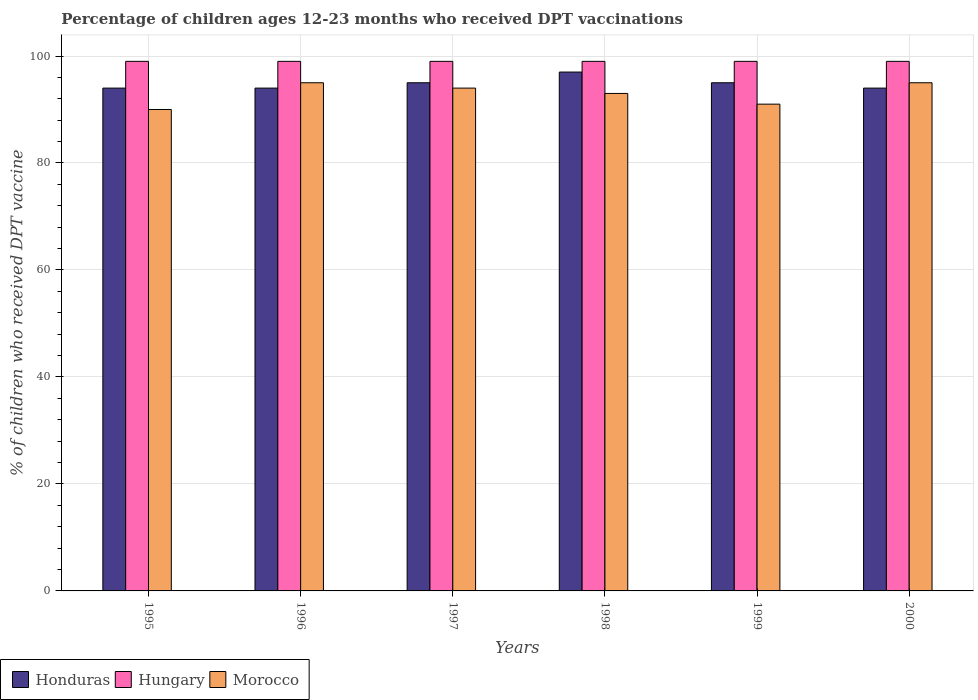How many bars are there on the 3rd tick from the left?
Make the answer very short. 3. What is the label of the 6th group of bars from the left?
Make the answer very short. 2000. In how many cases, is the number of bars for a given year not equal to the number of legend labels?
Offer a terse response. 0. What is the percentage of children who received DPT vaccination in Morocco in 2000?
Provide a succinct answer. 95. Across all years, what is the maximum percentage of children who received DPT vaccination in Hungary?
Provide a short and direct response. 99. Across all years, what is the minimum percentage of children who received DPT vaccination in Hungary?
Offer a very short reply. 99. In which year was the percentage of children who received DPT vaccination in Hungary minimum?
Offer a terse response. 1995. What is the total percentage of children who received DPT vaccination in Morocco in the graph?
Your answer should be compact. 558. What is the difference between the percentage of children who received DPT vaccination in Honduras in 1997 and that in 1999?
Offer a terse response. 0. What is the difference between the percentage of children who received DPT vaccination in Honduras in 1997 and the percentage of children who received DPT vaccination in Morocco in 1996?
Your response must be concise. 0. What is the average percentage of children who received DPT vaccination in Morocco per year?
Provide a short and direct response. 93. In the year 1998, what is the difference between the percentage of children who received DPT vaccination in Hungary and percentage of children who received DPT vaccination in Morocco?
Give a very brief answer. 6. In how many years, is the percentage of children who received DPT vaccination in Honduras greater than 80 %?
Offer a terse response. 6. What is the ratio of the percentage of children who received DPT vaccination in Honduras in 1998 to that in 1999?
Make the answer very short. 1.02. What is the difference between the highest and the second highest percentage of children who received DPT vaccination in Morocco?
Offer a very short reply. 0. Is the sum of the percentage of children who received DPT vaccination in Morocco in 1996 and 1999 greater than the maximum percentage of children who received DPT vaccination in Honduras across all years?
Make the answer very short. Yes. What does the 3rd bar from the left in 1997 represents?
Provide a short and direct response. Morocco. What does the 1st bar from the right in 1996 represents?
Keep it short and to the point. Morocco. Is it the case that in every year, the sum of the percentage of children who received DPT vaccination in Hungary and percentage of children who received DPT vaccination in Honduras is greater than the percentage of children who received DPT vaccination in Morocco?
Keep it short and to the point. Yes. Are all the bars in the graph horizontal?
Your answer should be very brief. No. How many years are there in the graph?
Keep it short and to the point. 6. Does the graph contain grids?
Keep it short and to the point. Yes. Where does the legend appear in the graph?
Offer a terse response. Bottom left. How many legend labels are there?
Make the answer very short. 3. What is the title of the graph?
Ensure brevity in your answer.  Percentage of children ages 12-23 months who received DPT vaccinations. Does "Sierra Leone" appear as one of the legend labels in the graph?
Your response must be concise. No. What is the label or title of the X-axis?
Provide a short and direct response. Years. What is the label or title of the Y-axis?
Your response must be concise. % of children who received DPT vaccine. What is the % of children who received DPT vaccine of Honduras in 1995?
Make the answer very short. 94. What is the % of children who received DPT vaccine in Hungary in 1995?
Your response must be concise. 99. What is the % of children who received DPT vaccine of Honduras in 1996?
Your response must be concise. 94. What is the % of children who received DPT vaccine of Hungary in 1996?
Provide a short and direct response. 99. What is the % of children who received DPT vaccine of Hungary in 1997?
Provide a succinct answer. 99. What is the % of children who received DPT vaccine in Morocco in 1997?
Offer a very short reply. 94. What is the % of children who received DPT vaccine of Honduras in 1998?
Your response must be concise. 97. What is the % of children who received DPT vaccine in Hungary in 1998?
Make the answer very short. 99. What is the % of children who received DPT vaccine in Morocco in 1998?
Give a very brief answer. 93. What is the % of children who received DPT vaccine of Hungary in 1999?
Provide a succinct answer. 99. What is the % of children who received DPT vaccine of Morocco in 1999?
Keep it short and to the point. 91. What is the % of children who received DPT vaccine in Honduras in 2000?
Your answer should be compact. 94. What is the % of children who received DPT vaccine in Hungary in 2000?
Your response must be concise. 99. What is the % of children who received DPT vaccine of Morocco in 2000?
Your response must be concise. 95. Across all years, what is the maximum % of children who received DPT vaccine in Honduras?
Your answer should be compact. 97. Across all years, what is the maximum % of children who received DPT vaccine in Hungary?
Provide a short and direct response. 99. Across all years, what is the minimum % of children who received DPT vaccine in Honduras?
Your answer should be compact. 94. Across all years, what is the minimum % of children who received DPT vaccine of Hungary?
Make the answer very short. 99. What is the total % of children who received DPT vaccine of Honduras in the graph?
Ensure brevity in your answer.  569. What is the total % of children who received DPT vaccine in Hungary in the graph?
Make the answer very short. 594. What is the total % of children who received DPT vaccine of Morocco in the graph?
Provide a succinct answer. 558. What is the difference between the % of children who received DPT vaccine of Hungary in 1995 and that in 1996?
Make the answer very short. 0. What is the difference between the % of children who received DPT vaccine in Honduras in 1995 and that in 1997?
Offer a very short reply. -1. What is the difference between the % of children who received DPT vaccine of Hungary in 1995 and that in 1998?
Ensure brevity in your answer.  0. What is the difference between the % of children who received DPT vaccine of Morocco in 1995 and that in 1998?
Give a very brief answer. -3. What is the difference between the % of children who received DPT vaccine of Honduras in 1995 and that in 1999?
Give a very brief answer. -1. What is the difference between the % of children who received DPT vaccine in Hungary in 1995 and that in 1999?
Provide a short and direct response. 0. What is the difference between the % of children who received DPT vaccine in Honduras in 1995 and that in 2000?
Keep it short and to the point. 0. What is the difference between the % of children who received DPT vaccine in Hungary in 1996 and that in 1997?
Offer a terse response. 0. What is the difference between the % of children who received DPT vaccine of Morocco in 1996 and that in 1997?
Ensure brevity in your answer.  1. What is the difference between the % of children who received DPT vaccine of Hungary in 1996 and that in 1998?
Offer a very short reply. 0. What is the difference between the % of children who received DPT vaccine in Morocco in 1996 and that in 1998?
Make the answer very short. 2. What is the difference between the % of children who received DPT vaccine in Honduras in 1996 and that in 1999?
Make the answer very short. -1. What is the difference between the % of children who received DPT vaccine in Morocco in 1996 and that in 1999?
Ensure brevity in your answer.  4. What is the difference between the % of children who received DPT vaccine of Hungary in 1996 and that in 2000?
Keep it short and to the point. 0. What is the difference between the % of children who received DPT vaccine in Morocco in 1996 and that in 2000?
Your response must be concise. 0. What is the difference between the % of children who received DPT vaccine of Hungary in 1997 and that in 1998?
Ensure brevity in your answer.  0. What is the difference between the % of children who received DPT vaccine in Morocco in 1997 and that in 1998?
Provide a succinct answer. 1. What is the difference between the % of children who received DPT vaccine in Honduras in 1997 and that in 1999?
Your response must be concise. 0. What is the difference between the % of children who received DPT vaccine of Morocco in 1997 and that in 1999?
Keep it short and to the point. 3. What is the difference between the % of children who received DPT vaccine in Hungary in 1997 and that in 2000?
Ensure brevity in your answer.  0. What is the difference between the % of children who received DPT vaccine in Morocco in 1997 and that in 2000?
Make the answer very short. -1. What is the difference between the % of children who received DPT vaccine of Honduras in 1998 and that in 1999?
Your answer should be compact. 2. What is the difference between the % of children who received DPT vaccine in Hungary in 1998 and that in 2000?
Provide a succinct answer. 0. What is the difference between the % of children who received DPT vaccine in Honduras in 1999 and that in 2000?
Make the answer very short. 1. What is the difference between the % of children who received DPT vaccine of Honduras in 1995 and the % of children who received DPT vaccine of Hungary in 1996?
Ensure brevity in your answer.  -5. What is the difference between the % of children who received DPT vaccine of Honduras in 1995 and the % of children who received DPT vaccine of Morocco in 1996?
Offer a terse response. -1. What is the difference between the % of children who received DPT vaccine of Honduras in 1995 and the % of children who received DPT vaccine of Hungary in 1997?
Make the answer very short. -5. What is the difference between the % of children who received DPT vaccine of Honduras in 1995 and the % of children who received DPT vaccine of Morocco in 1997?
Give a very brief answer. 0. What is the difference between the % of children who received DPT vaccine of Hungary in 1995 and the % of children who received DPT vaccine of Morocco in 1997?
Your response must be concise. 5. What is the difference between the % of children who received DPT vaccine in Honduras in 1995 and the % of children who received DPT vaccine in Morocco in 1998?
Make the answer very short. 1. What is the difference between the % of children who received DPT vaccine in Honduras in 1995 and the % of children who received DPT vaccine in Hungary in 1999?
Make the answer very short. -5. What is the difference between the % of children who received DPT vaccine of Hungary in 1995 and the % of children who received DPT vaccine of Morocco in 1999?
Offer a terse response. 8. What is the difference between the % of children who received DPT vaccine of Honduras in 1995 and the % of children who received DPT vaccine of Hungary in 2000?
Provide a succinct answer. -5. What is the difference between the % of children who received DPT vaccine in Honduras in 1995 and the % of children who received DPT vaccine in Morocco in 2000?
Provide a succinct answer. -1. What is the difference between the % of children who received DPT vaccine of Honduras in 1996 and the % of children who received DPT vaccine of Hungary in 1997?
Offer a very short reply. -5. What is the difference between the % of children who received DPT vaccine in Hungary in 1996 and the % of children who received DPT vaccine in Morocco in 1997?
Ensure brevity in your answer.  5. What is the difference between the % of children who received DPT vaccine in Honduras in 1996 and the % of children who received DPT vaccine in Hungary in 1998?
Your answer should be compact. -5. What is the difference between the % of children who received DPT vaccine of Honduras in 1996 and the % of children who received DPT vaccine of Morocco in 1998?
Keep it short and to the point. 1. What is the difference between the % of children who received DPT vaccine in Honduras in 1996 and the % of children who received DPT vaccine in Hungary in 1999?
Offer a very short reply. -5. What is the difference between the % of children who received DPT vaccine in Hungary in 1996 and the % of children who received DPT vaccine in Morocco in 1999?
Your answer should be compact. 8. What is the difference between the % of children who received DPT vaccine in Honduras in 1996 and the % of children who received DPT vaccine in Morocco in 2000?
Ensure brevity in your answer.  -1. What is the difference between the % of children who received DPT vaccine in Hungary in 1996 and the % of children who received DPT vaccine in Morocco in 2000?
Your answer should be compact. 4. What is the difference between the % of children who received DPT vaccine in Honduras in 1997 and the % of children who received DPT vaccine in Morocco in 1998?
Your answer should be very brief. 2. What is the difference between the % of children who received DPT vaccine of Hungary in 1997 and the % of children who received DPT vaccine of Morocco in 1998?
Your answer should be compact. 6. What is the difference between the % of children who received DPT vaccine of Honduras in 1997 and the % of children who received DPT vaccine of Hungary in 1999?
Your answer should be very brief. -4. What is the difference between the % of children who received DPT vaccine in Hungary in 1997 and the % of children who received DPT vaccine in Morocco in 1999?
Ensure brevity in your answer.  8. What is the difference between the % of children who received DPT vaccine in Honduras in 1998 and the % of children who received DPT vaccine in Hungary in 1999?
Offer a terse response. -2. What is the difference between the % of children who received DPT vaccine in Honduras in 1998 and the % of children who received DPT vaccine in Morocco in 2000?
Provide a short and direct response. 2. What is the difference between the % of children who received DPT vaccine in Honduras in 1999 and the % of children who received DPT vaccine in Morocco in 2000?
Keep it short and to the point. 0. What is the difference between the % of children who received DPT vaccine in Hungary in 1999 and the % of children who received DPT vaccine in Morocco in 2000?
Ensure brevity in your answer.  4. What is the average % of children who received DPT vaccine of Honduras per year?
Provide a short and direct response. 94.83. What is the average % of children who received DPT vaccine of Morocco per year?
Offer a terse response. 93. In the year 1995, what is the difference between the % of children who received DPT vaccine in Honduras and % of children who received DPT vaccine in Morocco?
Your answer should be very brief. 4. In the year 1996, what is the difference between the % of children who received DPT vaccine in Honduras and % of children who received DPT vaccine in Hungary?
Keep it short and to the point. -5. In the year 1997, what is the difference between the % of children who received DPT vaccine in Honduras and % of children who received DPT vaccine in Hungary?
Make the answer very short. -4. In the year 1997, what is the difference between the % of children who received DPT vaccine in Hungary and % of children who received DPT vaccine in Morocco?
Make the answer very short. 5. In the year 1998, what is the difference between the % of children who received DPT vaccine of Honduras and % of children who received DPT vaccine of Hungary?
Ensure brevity in your answer.  -2. In the year 1998, what is the difference between the % of children who received DPT vaccine of Hungary and % of children who received DPT vaccine of Morocco?
Your response must be concise. 6. In the year 1999, what is the difference between the % of children who received DPT vaccine of Honduras and % of children who received DPT vaccine of Hungary?
Your answer should be compact. -4. In the year 1999, what is the difference between the % of children who received DPT vaccine of Honduras and % of children who received DPT vaccine of Morocco?
Offer a terse response. 4. In the year 1999, what is the difference between the % of children who received DPT vaccine of Hungary and % of children who received DPT vaccine of Morocco?
Ensure brevity in your answer.  8. What is the ratio of the % of children who received DPT vaccine of Hungary in 1995 to that in 1996?
Your answer should be very brief. 1. What is the ratio of the % of children who received DPT vaccine of Morocco in 1995 to that in 1996?
Ensure brevity in your answer.  0.95. What is the ratio of the % of children who received DPT vaccine in Morocco in 1995 to that in 1997?
Provide a short and direct response. 0.96. What is the ratio of the % of children who received DPT vaccine of Honduras in 1995 to that in 1998?
Your response must be concise. 0.97. What is the ratio of the % of children who received DPT vaccine in Morocco in 1995 to that in 1998?
Provide a short and direct response. 0.97. What is the ratio of the % of children who received DPT vaccine in Hungary in 1995 to that in 1999?
Make the answer very short. 1. What is the ratio of the % of children who received DPT vaccine of Honduras in 1995 to that in 2000?
Give a very brief answer. 1. What is the ratio of the % of children who received DPT vaccine in Hungary in 1995 to that in 2000?
Your response must be concise. 1. What is the ratio of the % of children who received DPT vaccine of Honduras in 1996 to that in 1997?
Provide a short and direct response. 0.99. What is the ratio of the % of children who received DPT vaccine in Morocco in 1996 to that in 1997?
Your answer should be compact. 1.01. What is the ratio of the % of children who received DPT vaccine in Honduras in 1996 to that in 1998?
Make the answer very short. 0.97. What is the ratio of the % of children who received DPT vaccine of Morocco in 1996 to that in 1998?
Ensure brevity in your answer.  1.02. What is the ratio of the % of children who received DPT vaccine in Morocco in 1996 to that in 1999?
Ensure brevity in your answer.  1.04. What is the ratio of the % of children who received DPT vaccine of Hungary in 1996 to that in 2000?
Provide a short and direct response. 1. What is the ratio of the % of children who received DPT vaccine of Honduras in 1997 to that in 1998?
Provide a short and direct response. 0.98. What is the ratio of the % of children who received DPT vaccine in Morocco in 1997 to that in 1998?
Your answer should be compact. 1.01. What is the ratio of the % of children who received DPT vaccine in Morocco in 1997 to that in 1999?
Offer a very short reply. 1.03. What is the ratio of the % of children who received DPT vaccine of Honduras in 1997 to that in 2000?
Offer a very short reply. 1.01. What is the ratio of the % of children who received DPT vaccine in Honduras in 1998 to that in 1999?
Your answer should be compact. 1.02. What is the ratio of the % of children who received DPT vaccine in Hungary in 1998 to that in 1999?
Give a very brief answer. 1. What is the ratio of the % of children who received DPT vaccine of Honduras in 1998 to that in 2000?
Make the answer very short. 1.03. What is the ratio of the % of children who received DPT vaccine of Morocco in 1998 to that in 2000?
Your answer should be compact. 0.98. What is the ratio of the % of children who received DPT vaccine in Honduras in 1999 to that in 2000?
Give a very brief answer. 1.01. What is the ratio of the % of children who received DPT vaccine in Morocco in 1999 to that in 2000?
Provide a succinct answer. 0.96. What is the difference between the highest and the second highest % of children who received DPT vaccine of Honduras?
Provide a short and direct response. 2. What is the difference between the highest and the second highest % of children who received DPT vaccine of Hungary?
Provide a short and direct response. 0. 